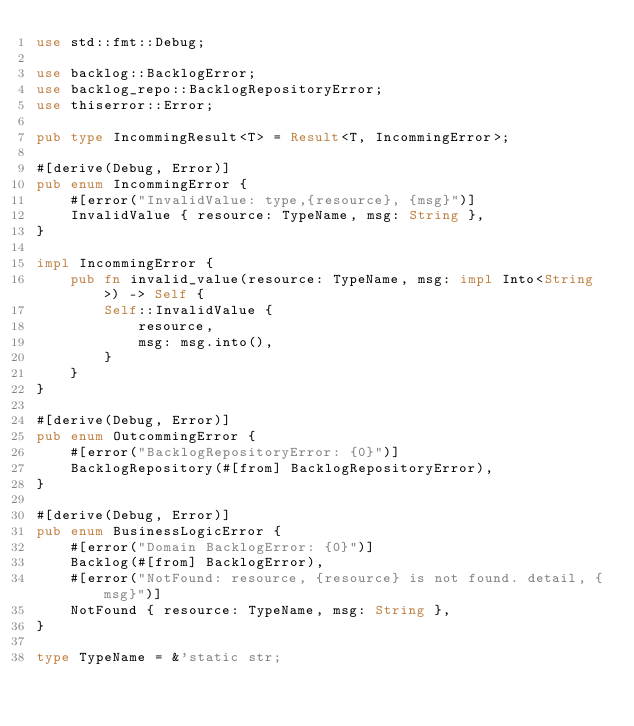Convert code to text. <code><loc_0><loc_0><loc_500><loc_500><_Rust_>use std::fmt::Debug;

use backlog::BacklogError;
use backlog_repo::BacklogRepositoryError;
use thiserror::Error;

pub type IncommingResult<T> = Result<T, IncommingError>;

#[derive(Debug, Error)]
pub enum IncommingError {
    #[error("InvalidValue: type,{resource}, {msg}")]
    InvalidValue { resource: TypeName, msg: String },
}

impl IncommingError {
    pub fn invalid_value(resource: TypeName, msg: impl Into<String>) -> Self {
        Self::InvalidValue {
            resource,
            msg: msg.into(),
        }
    }
}

#[derive(Debug, Error)]
pub enum OutcommingError {
    #[error("BacklogRepositoryError: {0}")]
    BacklogRepository(#[from] BacklogRepositoryError),
}

#[derive(Debug, Error)]
pub enum BusinessLogicError {
    #[error("Domain BacklogError: {0}")]
    Backlog(#[from] BacklogError),
    #[error("NotFound: resource, {resource} is not found. detail, {msg}")]
    NotFound { resource: TypeName, msg: String },
}

type TypeName = &'static str;
</code> 